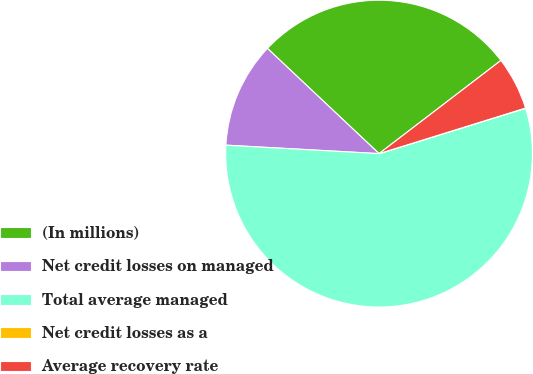<chart> <loc_0><loc_0><loc_500><loc_500><pie_chart><fcel>(In millions)<fcel>Net credit losses on managed<fcel>Total average managed<fcel>Net credit losses as a<fcel>Average recovery rate<nl><fcel>27.58%<fcel>11.15%<fcel>55.66%<fcel>0.02%<fcel>5.59%<nl></chart> 